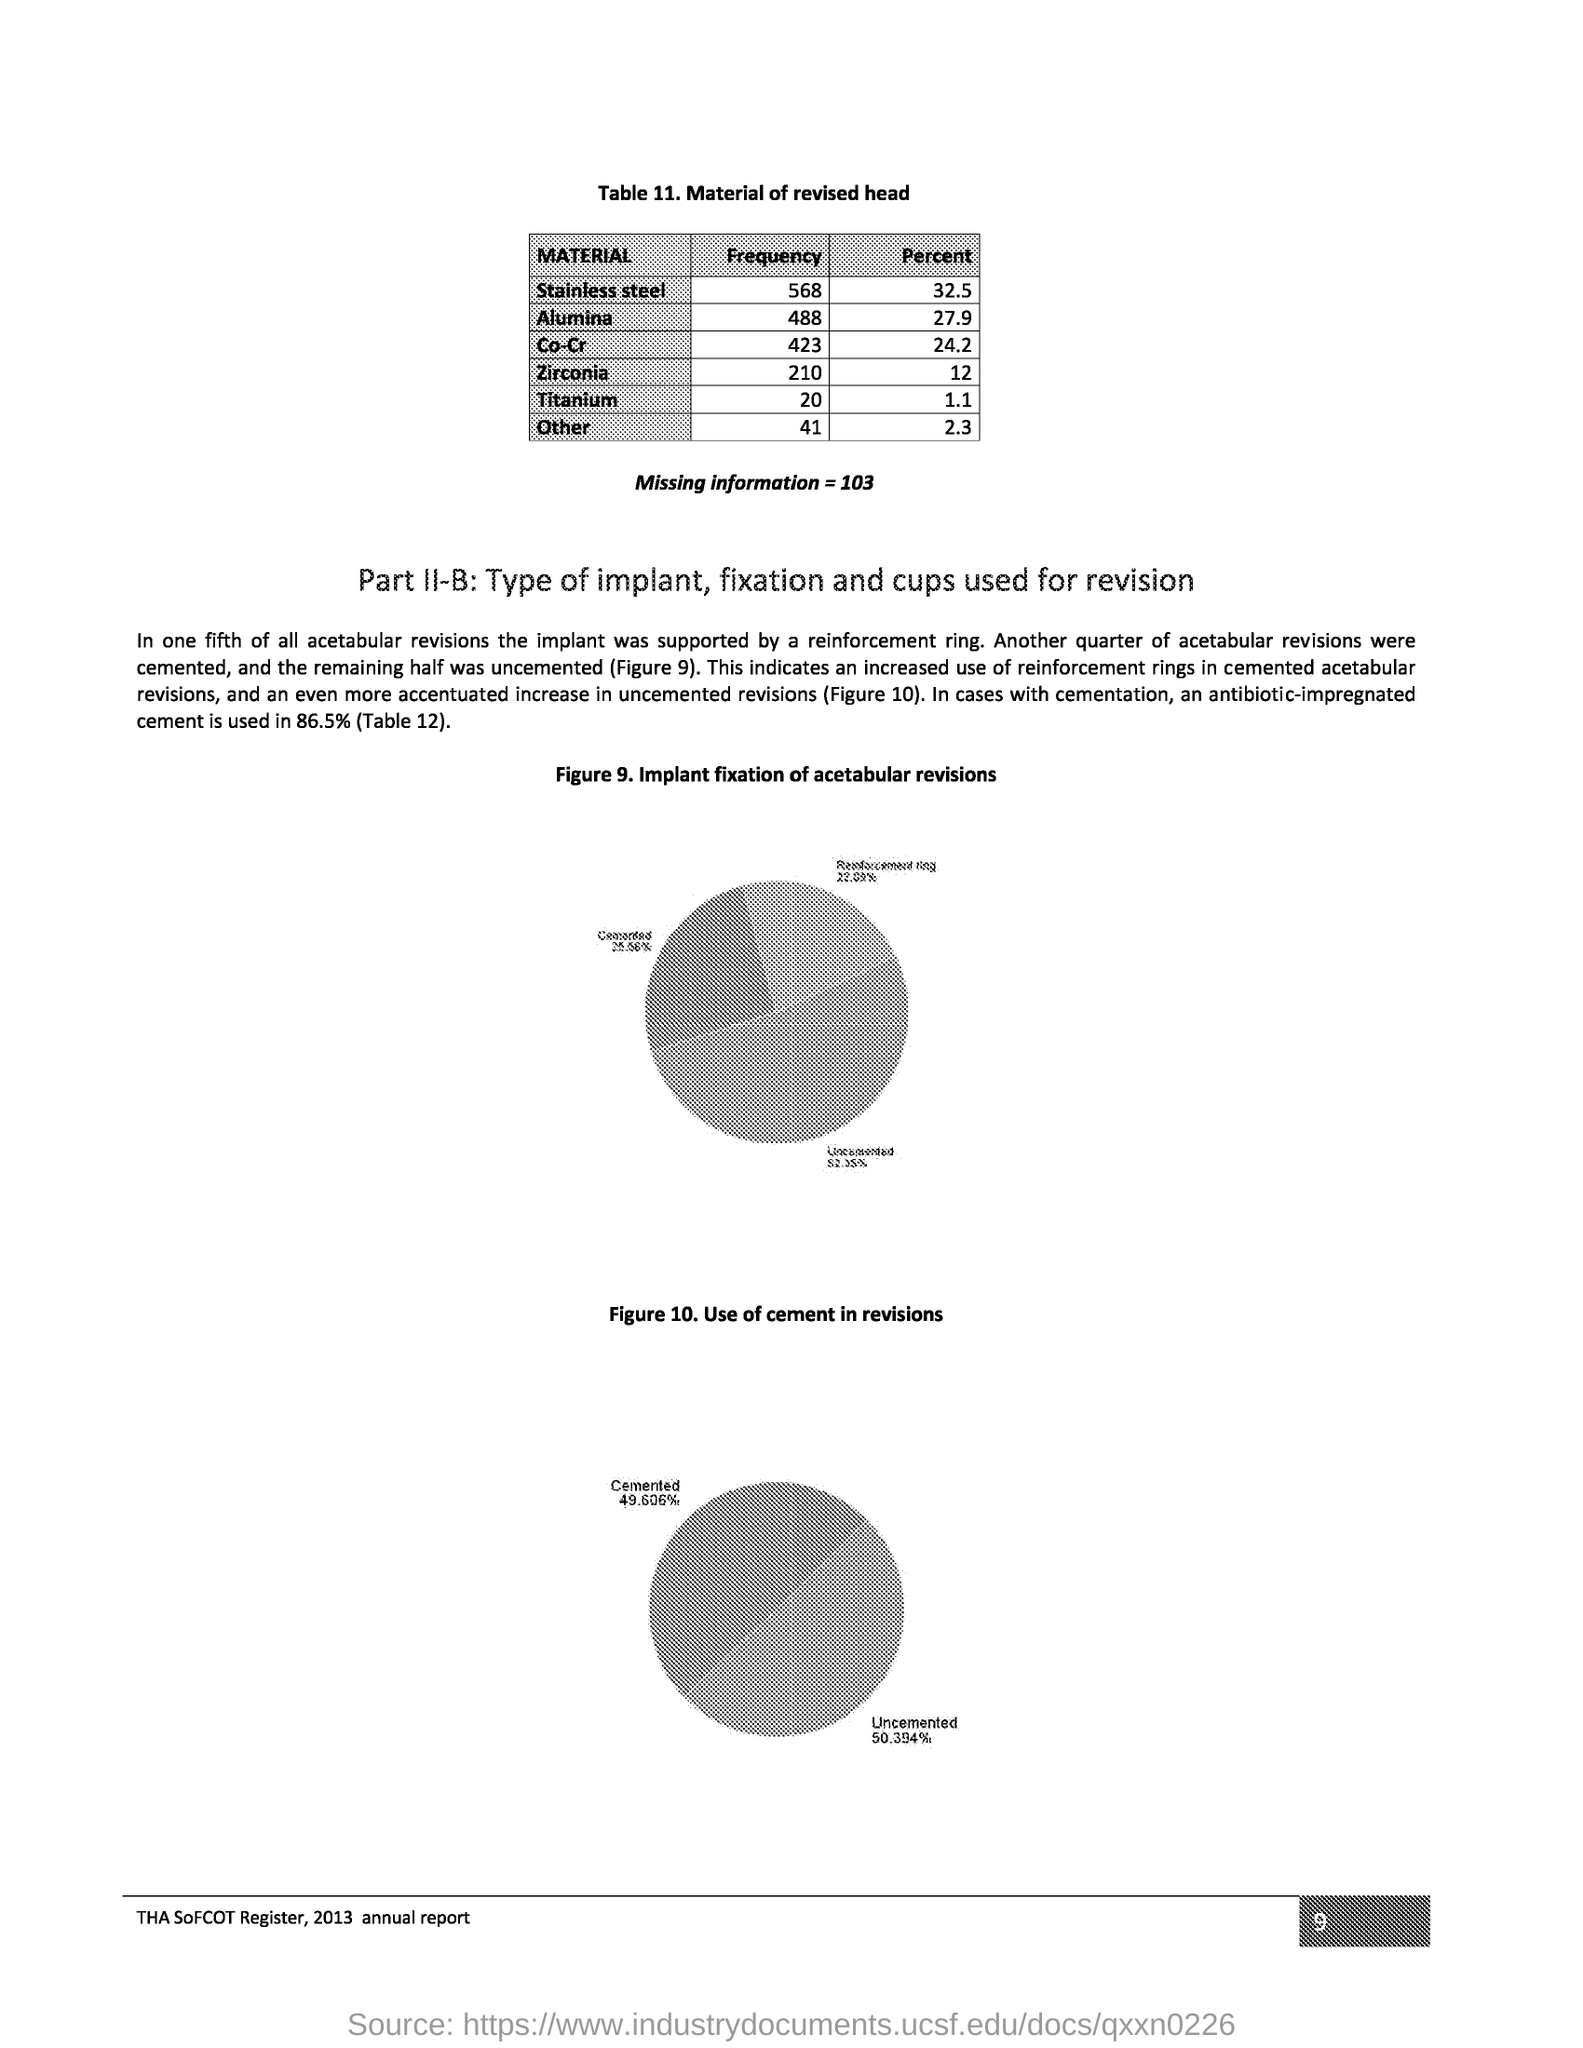What is the heading of Table 11?
Your answer should be compact. Material of revised head. What is the frequency of stainless steel?
Your response must be concise. 568. What is the percent of alumina?
Offer a terse response. 27.9. What is the title of figure 9?
Your answer should be very brief. Implant fixation of acetabular revisions. What was the implant supported by in one fifth of all acetabular revisions?
Ensure brevity in your answer.  A reinforcement ring. What is the percentage of an antibiotic-impregnated cement used?
Your answer should be compact. 86.5%. What is the percentage of cemented revisions as per figure 10?
Your answer should be very brief. 49.606%. What is the page number?
Offer a terse response. 9. It is the annual report of which year?
Offer a terse response. 2013. 